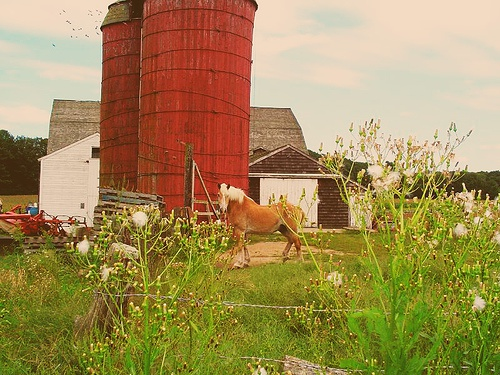Describe the objects in this image and their specific colors. I can see a horse in tan, brown, and maroon tones in this image. 